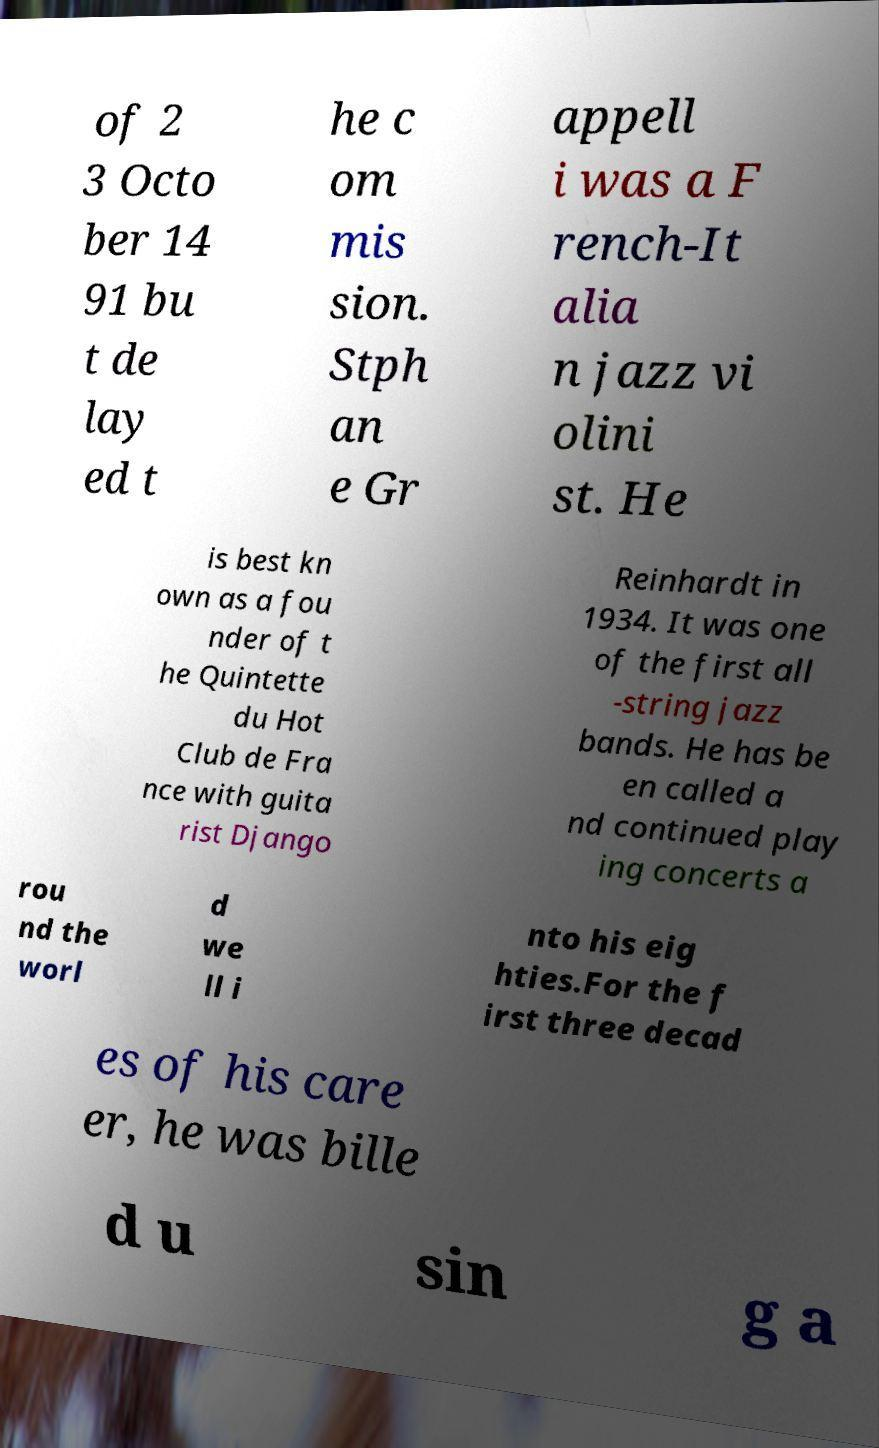Can you accurately transcribe the text from the provided image for me? of 2 3 Octo ber 14 91 bu t de lay ed t he c om mis sion. Stph an e Gr appell i was a F rench-It alia n jazz vi olini st. He is best kn own as a fou nder of t he Quintette du Hot Club de Fra nce with guita rist Django Reinhardt in 1934. It was one of the first all -string jazz bands. He has be en called a nd continued play ing concerts a rou nd the worl d we ll i nto his eig hties.For the f irst three decad es of his care er, he was bille d u sin g a 